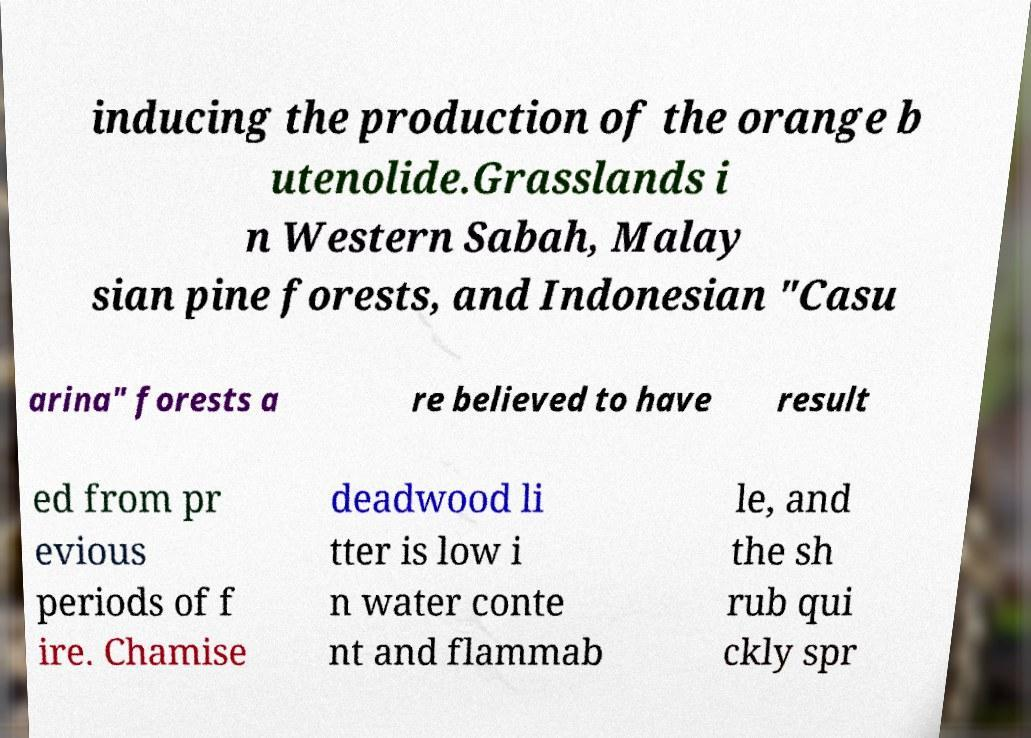Can you read and provide the text displayed in the image?This photo seems to have some interesting text. Can you extract and type it out for me? inducing the production of the orange b utenolide.Grasslands i n Western Sabah, Malay sian pine forests, and Indonesian "Casu arina" forests a re believed to have result ed from pr evious periods of f ire. Chamise deadwood li tter is low i n water conte nt and flammab le, and the sh rub qui ckly spr 